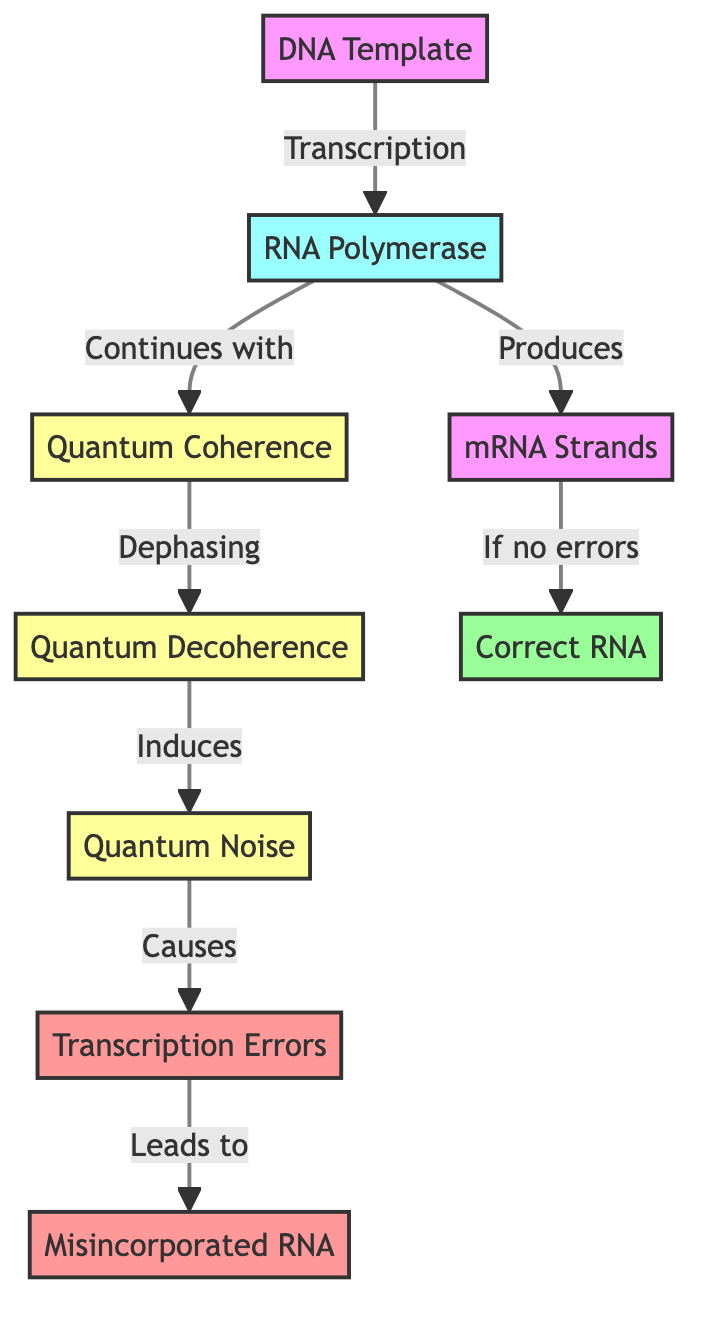What is the start node of the diagram? The start node, from which the process of transcription begins, is labeled "DNA Template". It is the initial input in the flow of transcription leading to the RNA synthesis process.
Answer: DNA Template How many edges are there in the diagram? By observing the connections between nodes, there are a total of six defined edges that represent the flow of transcription and the relationships between various components.
Answer: 6 What does "RNA Polymerase" produce if there are no errors? Following the flow from "RNA Polymerase" to "mRNA Strands" and then to "Correct RNA", it can be concluded that "RNA Polymerase" produces "Correct RNA" if no transcription errors occur.
Answer: Correct RNA What induces "Quantum Noise" according to the diagram? The diagram shows that "Quantum Decoherence" induces "Quantum Noise", following the dephasing process outlined in the flow from "Quantum Coherence" to "Quantum Decoherence" and then to "Quantum Noise".
Answer: Quantum Decoherence What type of errors are connected to "Misincorporated RNA"? The directed flow from "Transcription Errors" leads directly to "Misincorporated RNA". Thus, it can be concluded that these are the types of errors resulting from the transcription process.
Answer: Transcription Errors Why do "Quantum Noise" effects cause misincorporations? The diagram illustrates that "Quantum Noise" causes "Transcription Errors", which are misincorporations in the mRNA strands. It links quantum noise to biochemical inaccuracies during transcription that lead to incorrect RNA synthesis.
Answer: Transcription Errors How does "Quantum Coherence" relate to "RNA Polymerase"? In the flow from "RNA Polymerase" to "Quantum Coherence", it can be inferred that "RNA Polymerase" continues with "Quantum Coherence", suggesting that this coherence is maintained in the transcription process initiated by the enzyme.
Answer: Continues with What is the classification of "Transcription Errors"? The "Transcription Errors" node is classified under the style designated for errors, as indicated by the color coding in the diagram which distinctly labels errors in red.
Answer: error 